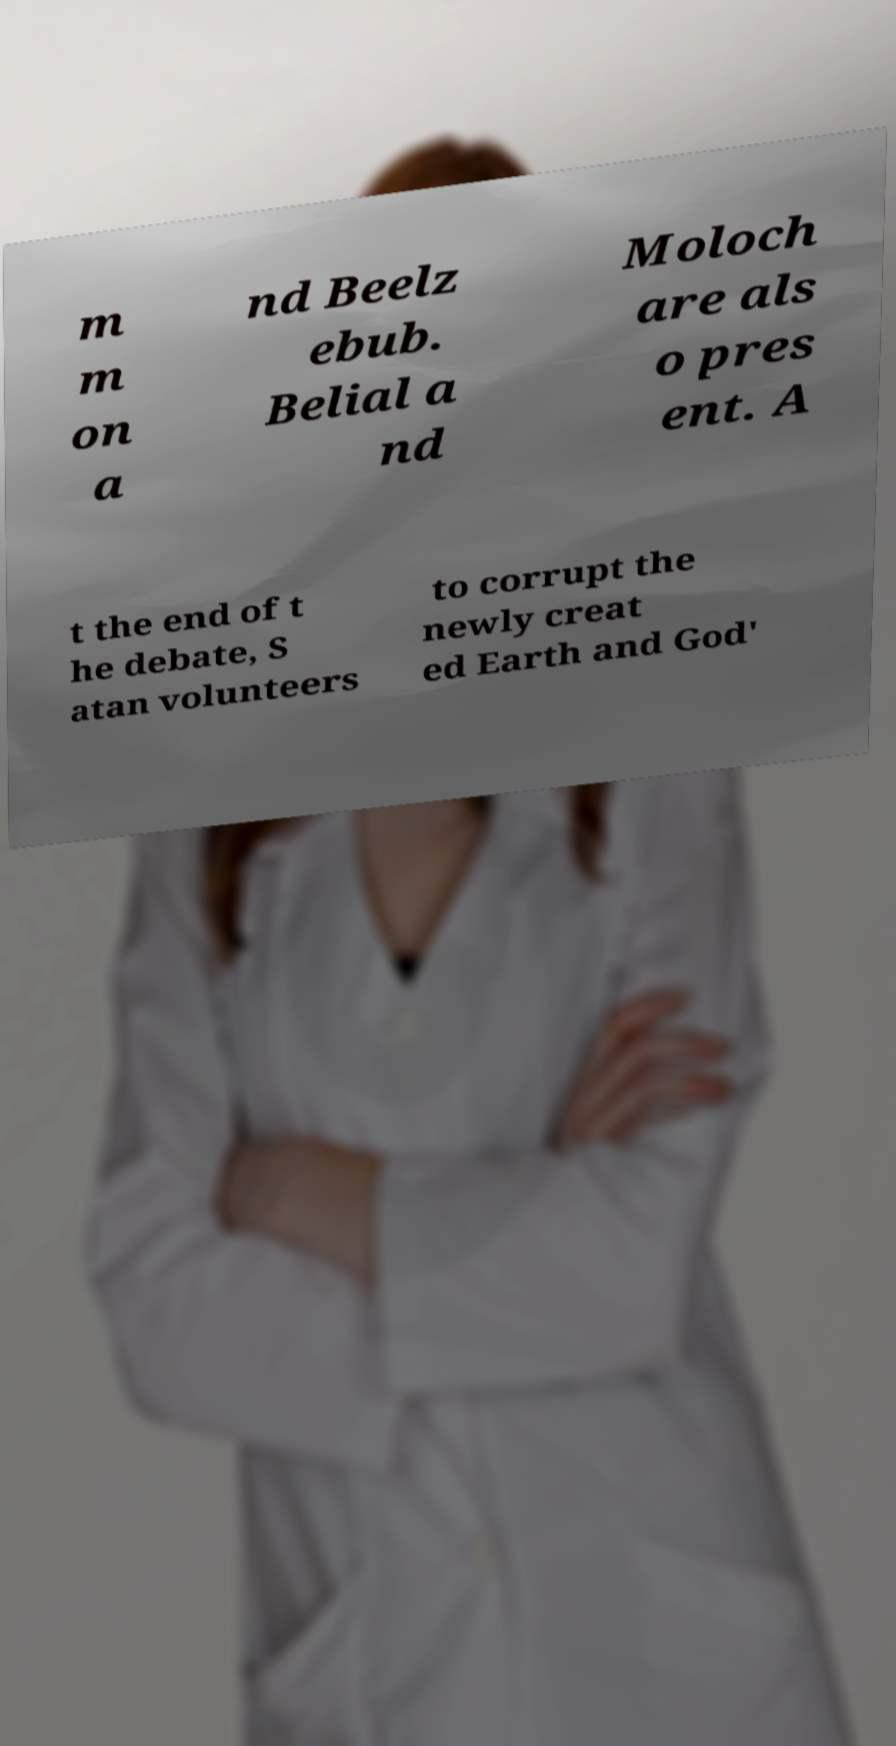What messages or text are displayed in this image? I need them in a readable, typed format. m m on a nd Beelz ebub. Belial a nd Moloch are als o pres ent. A t the end of t he debate, S atan volunteers to corrupt the newly creat ed Earth and God' 